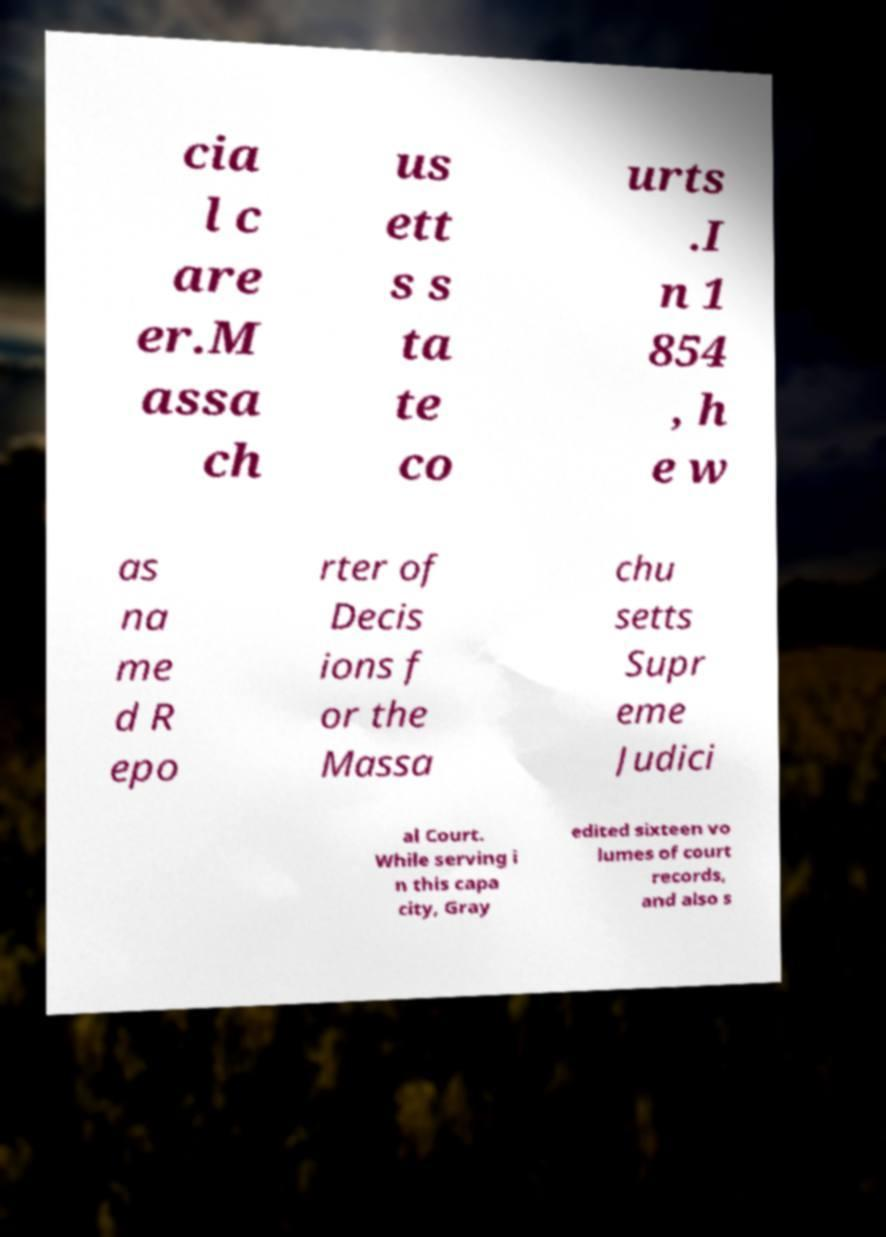Can you read and provide the text displayed in the image?This photo seems to have some interesting text. Can you extract and type it out for me? cia l c are er.M assa ch us ett s s ta te co urts .I n 1 854 , h e w as na me d R epo rter of Decis ions f or the Massa chu setts Supr eme Judici al Court. While serving i n this capa city, Gray edited sixteen vo lumes of court records, and also s 